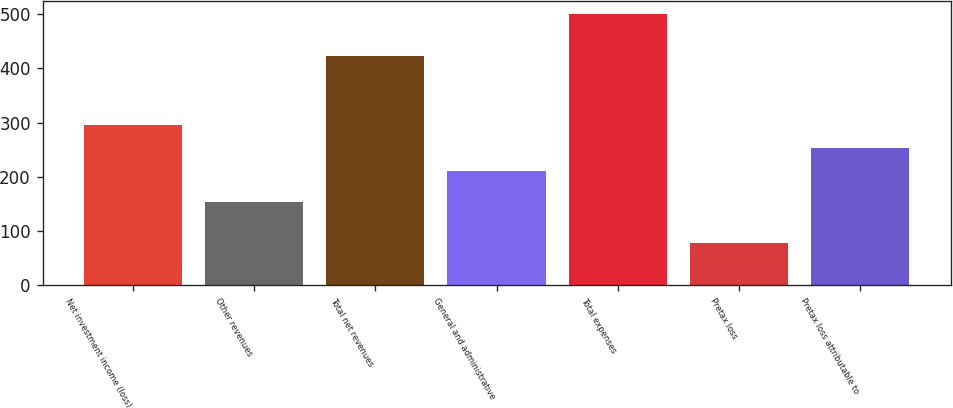<chart> <loc_0><loc_0><loc_500><loc_500><bar_chart><fcel>Net investment income (loss)<fcel>Other revenues<fcel>Total net revenues<fcel>General and administrative<fcel>Total expenses<fcel>Pretax loss<fcel>Pretax loss attributable to<nl><fcel>295.6<fcel>153<fcel>423<fcel>211<fcel>500<fcel>77<fcel>253.3<nl></chart> 